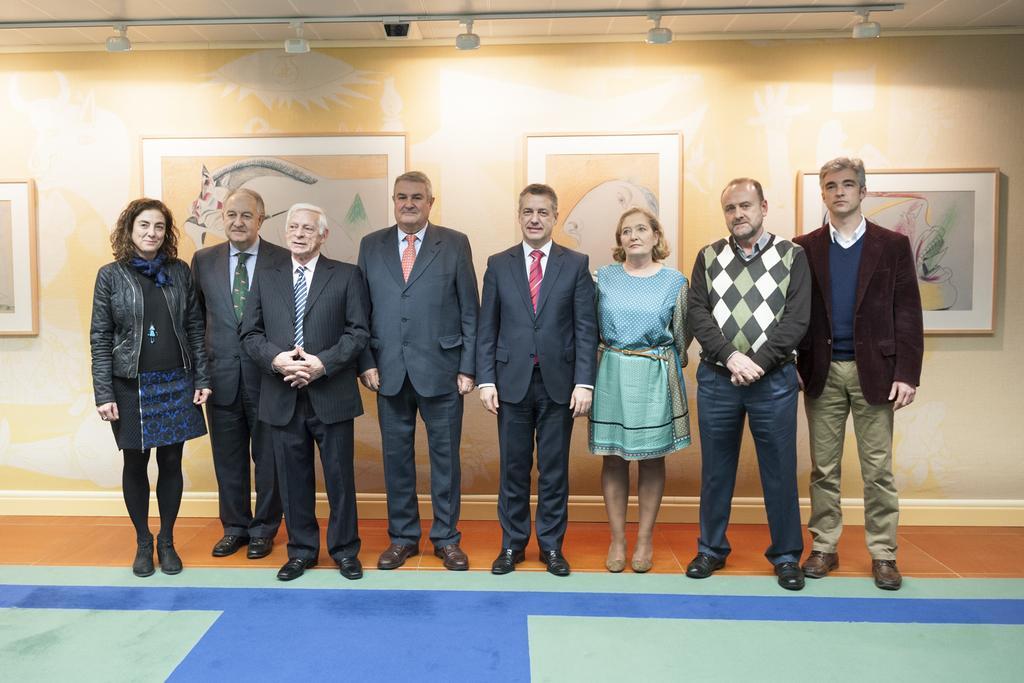Can you describe this image briefly? In this image we can see some people standing on the floor. We can also see some ceiling lights, roof and some photo frames on the wall. 